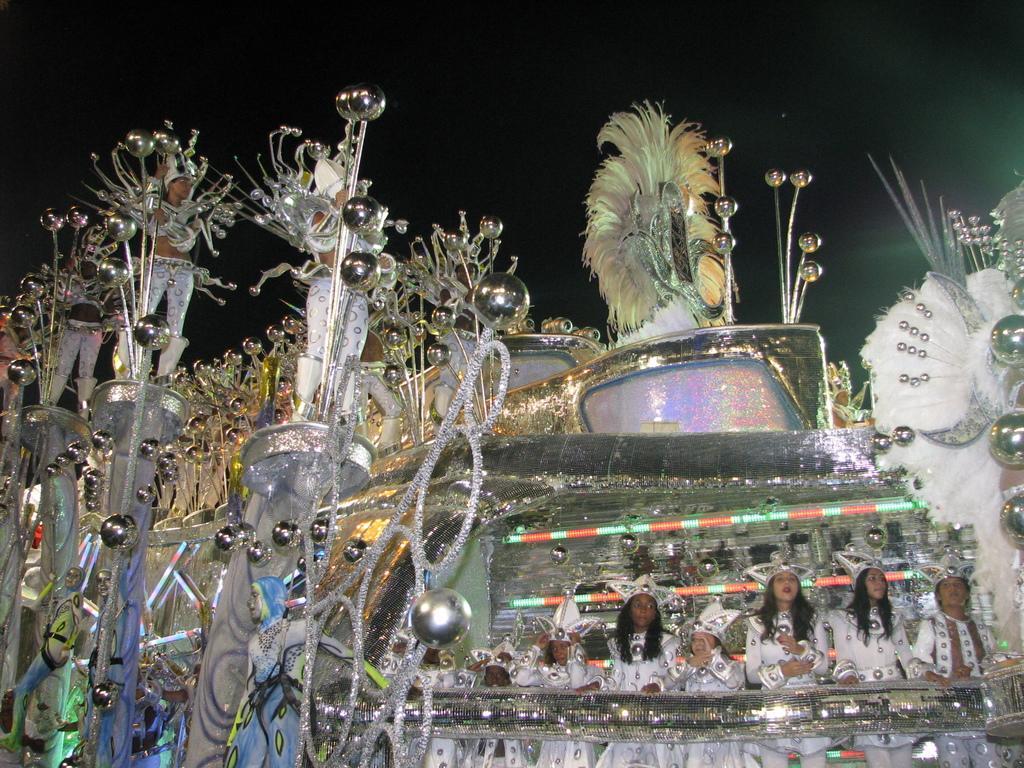Describe this image in one or two sentences. In this image we can see some people in costumes standing and holding objects. There is one decorated object looks like a vehicle and the background is dark. 